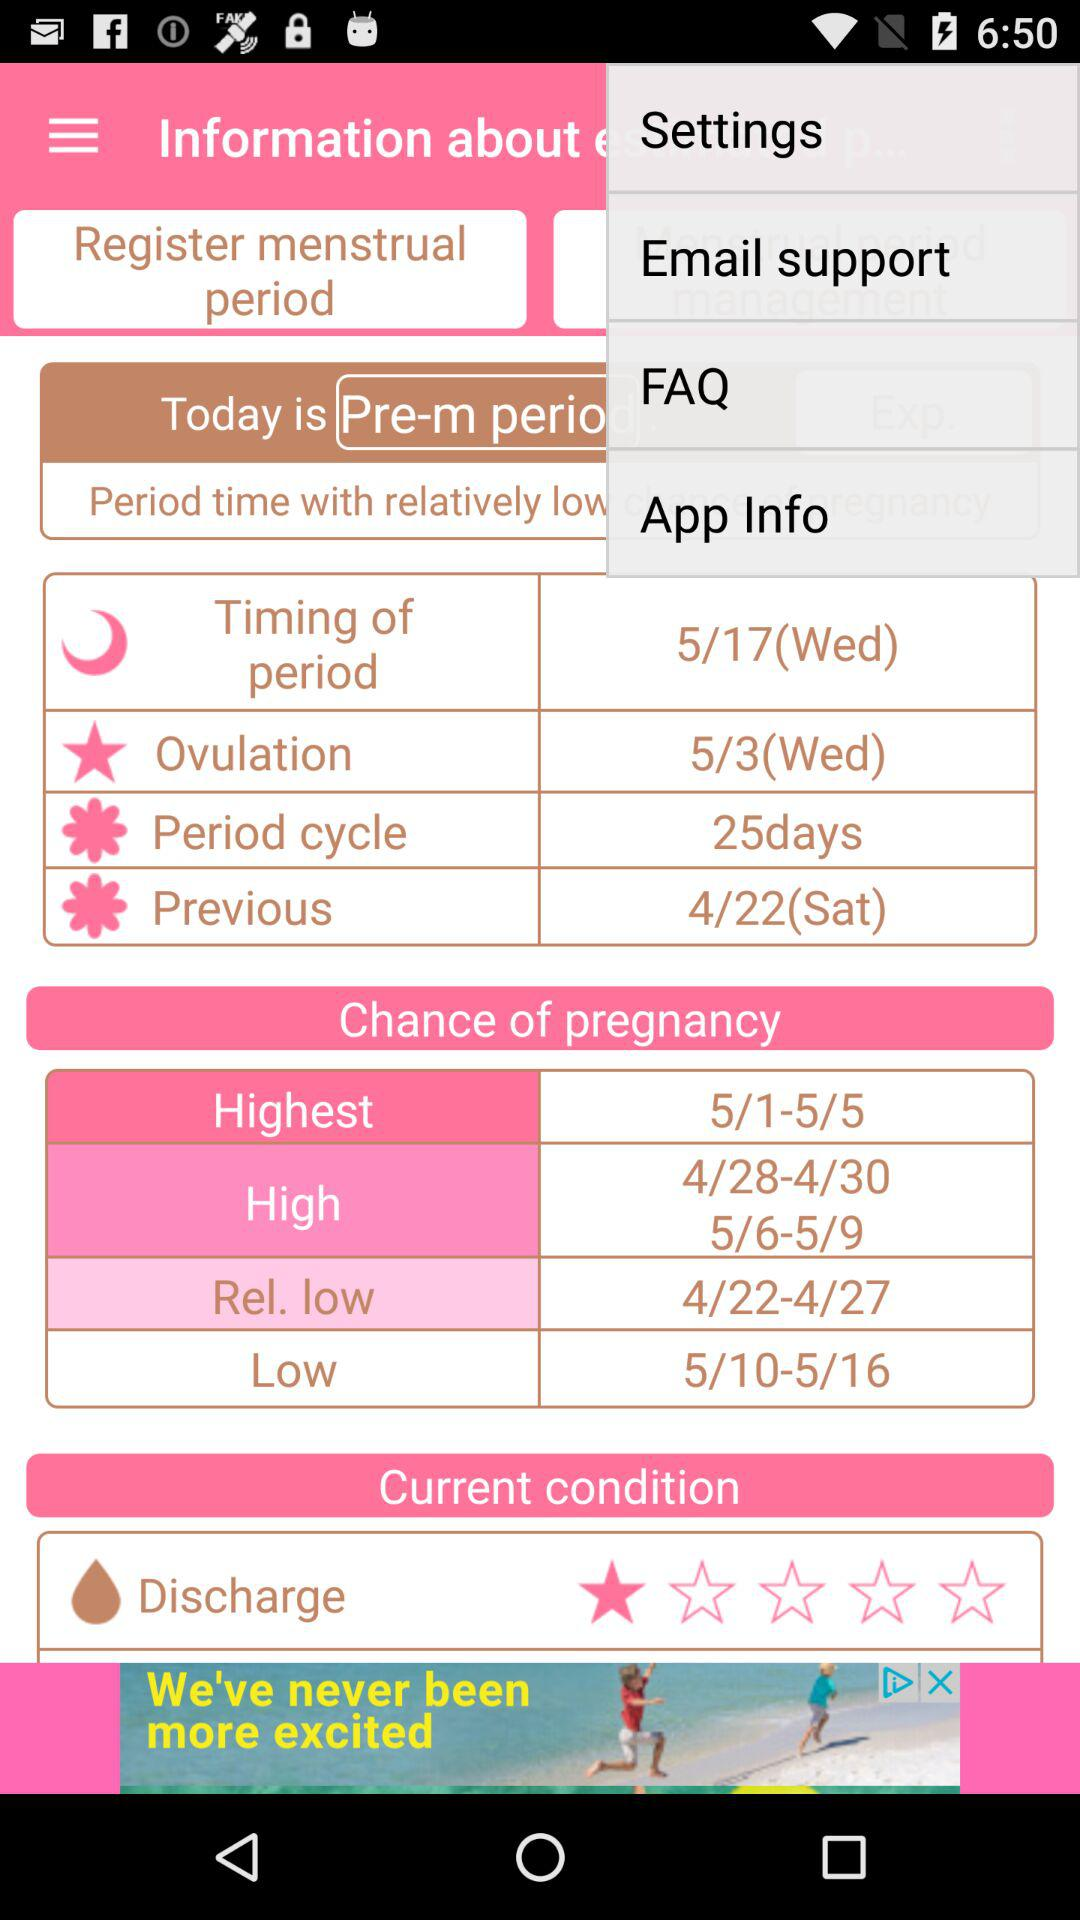What is the period cycle? The period cycle is 25 days. 